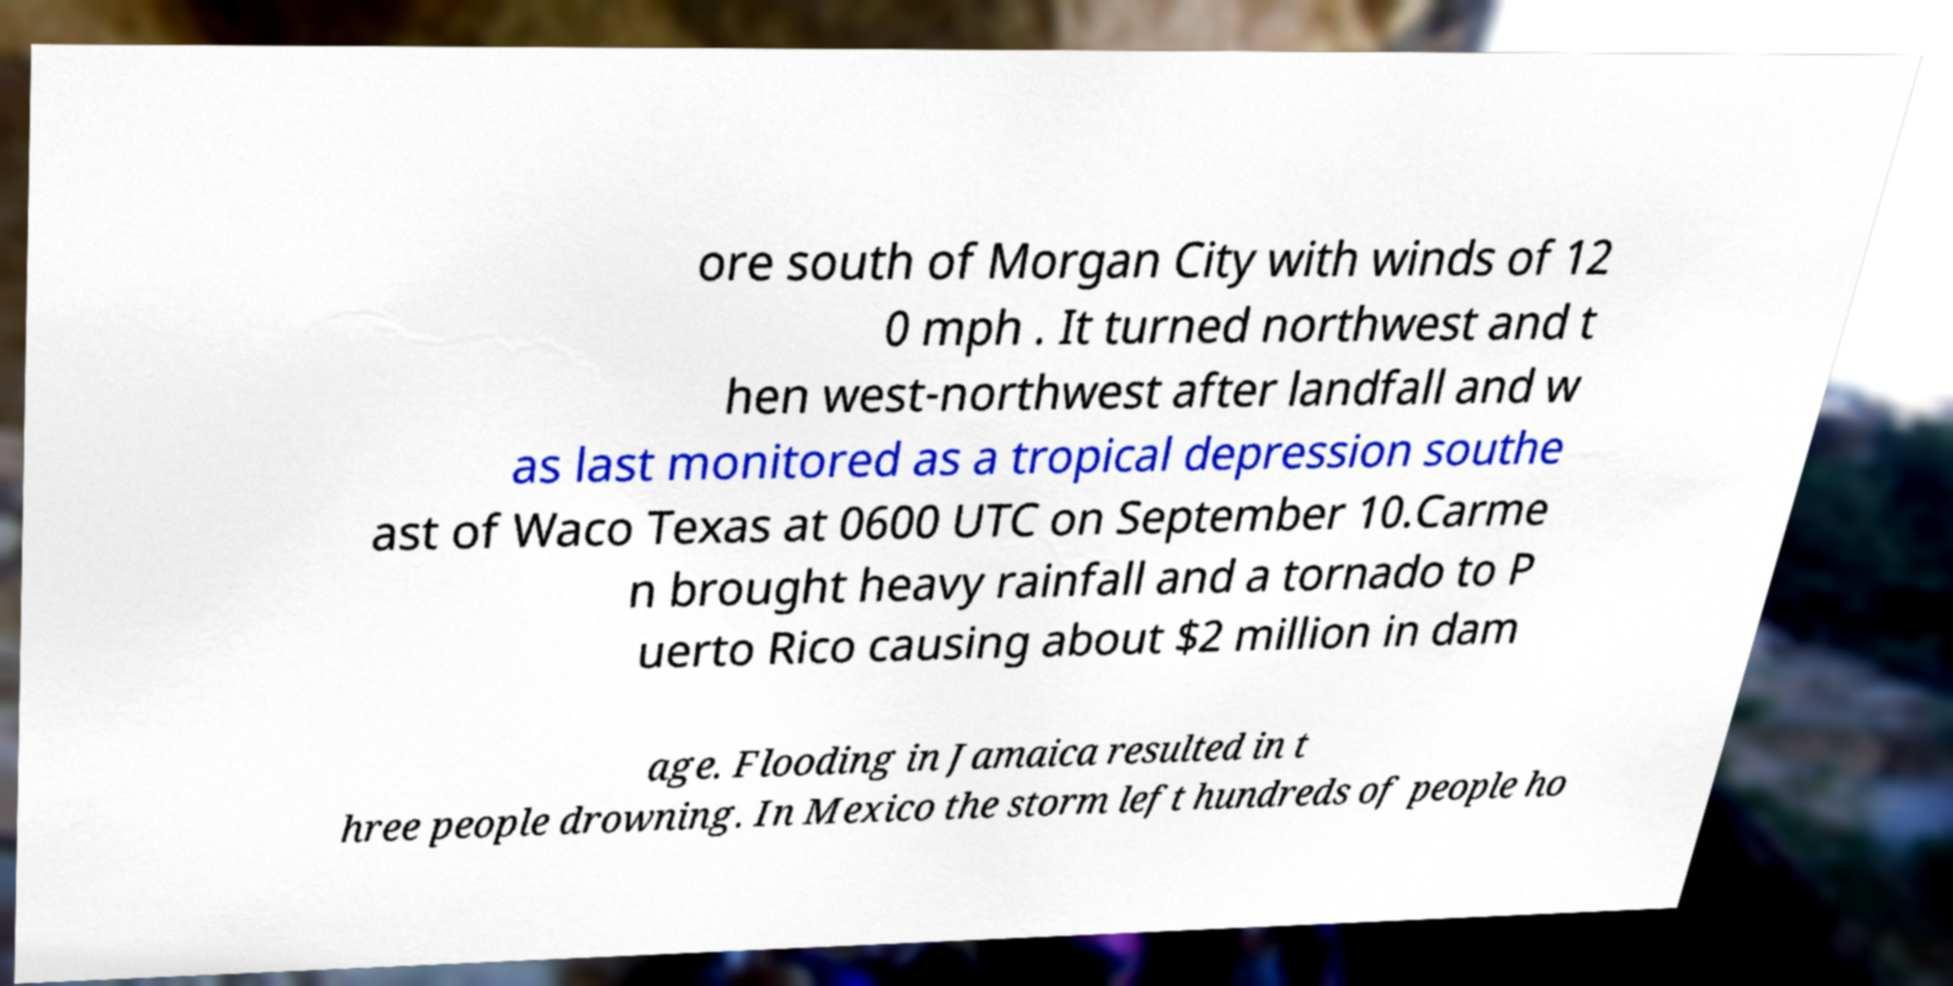For documentation purposes, I need the text within this image transcribed. Could you provide that? ore south of Morgan City with winds of 12 0 mph . It turned northwest and t hen west-northwest after landfall and w as last monitored as a tropical depression southe ast of Waco Texas at 0600 UTC on September 10.Carme n brought heavy rainfall and a tornado to P uerto Rico causing about $2 million in dam age. Flooding in Jamaica resulted in t hree people drowning. In Mexico the storm left hundreds of people ho 